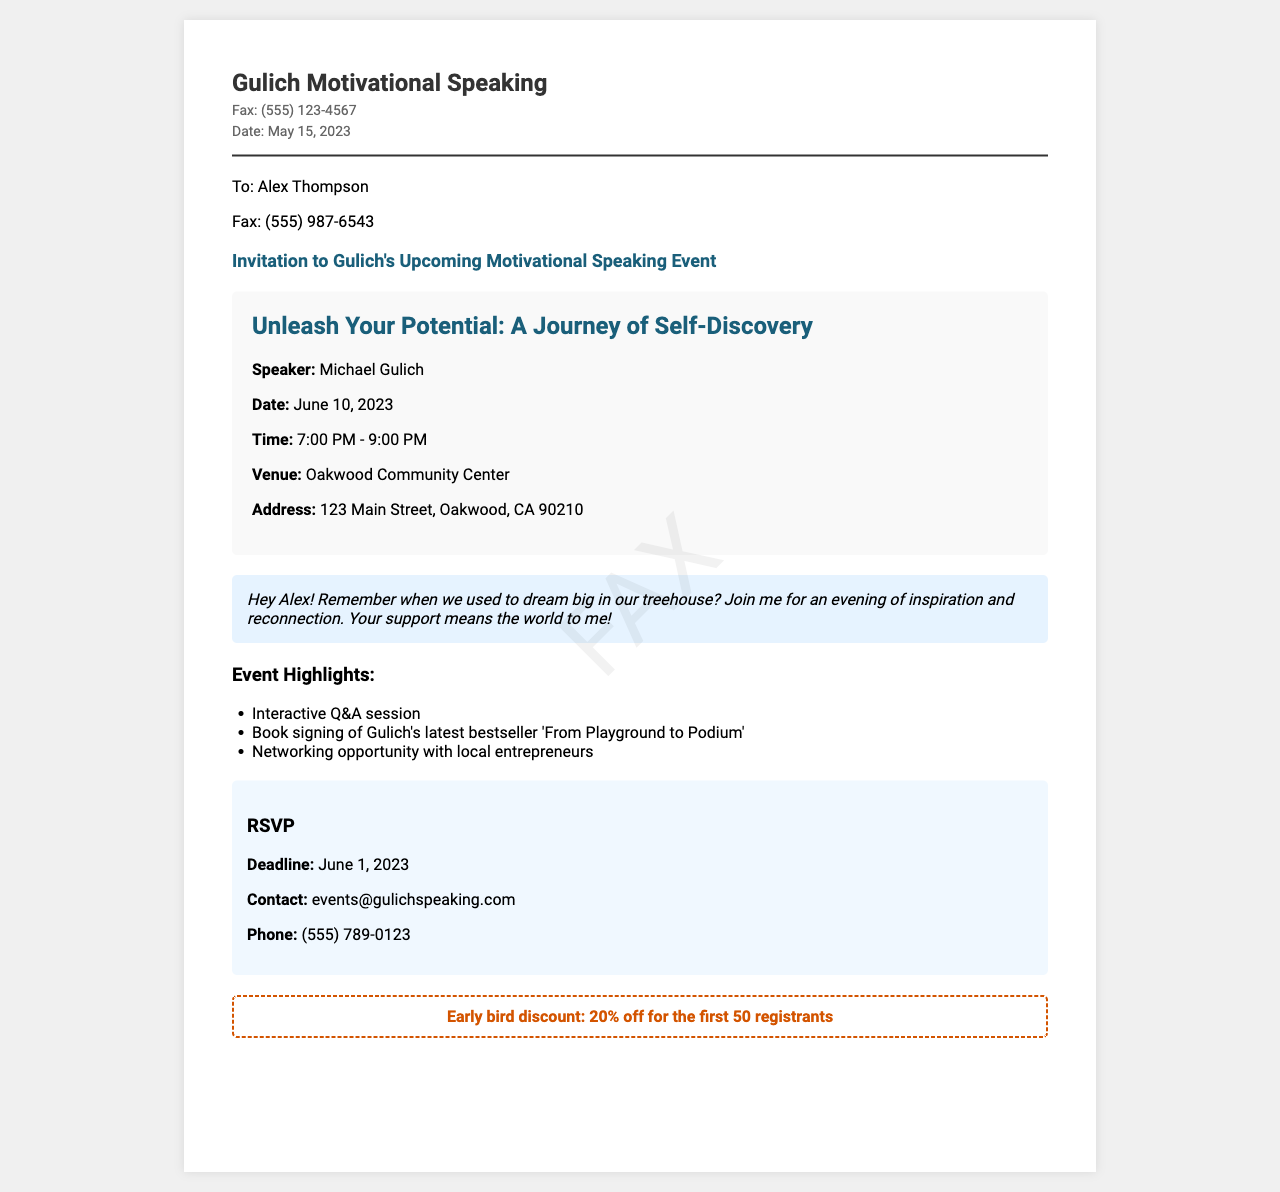What is the title of the event? The title of the event is presented in the event details section, which is "Unleash Your Potential: A Journey of Self-Discovery".
Answer: Unleash Your Potential: A Journey of Self-Discovery Who is the speaker for the event? The document specifies that the speaker is Michael Gulich, mentioned in the event details section.
Answer: Michael Gulich What is the date of the event? The event's date is found in the event details section, specifically listed as June 10, 2023.
Answer: June 10, 2023 What time does the event start? The time of the event is indicated in the event details section, which states it starts at 7:00 PM.
Answer: 7:00 PM What is the RSVP deadline? The RSVP deadline is noted in the RSVP section of the document, which is June 1, 2023.
Answer: June 1, 2023 What is the address of the venue? The venue's address is provided in the event details section as 123 Main Street, Oakwood, CA 90210.
Answer: 123 Main Street, Oakwood, CA 90210 What is offered for early bird registrants? The document mentions a special offer for early registrants, specifically stating a 20% discount for the first 50 registrants.
Answer: 20% off for the first 50 registrants What type of session is highlighted at the event? The event highlights an interactive session mentioned in the highlights section.
Answer: Interactive Q&A session What kind of contact information is provided for RSVPs? The RSVP section provides contact information, including email and phone number for further queries.
Answer: events@gulichspeaking.com and (555) 789-0123 